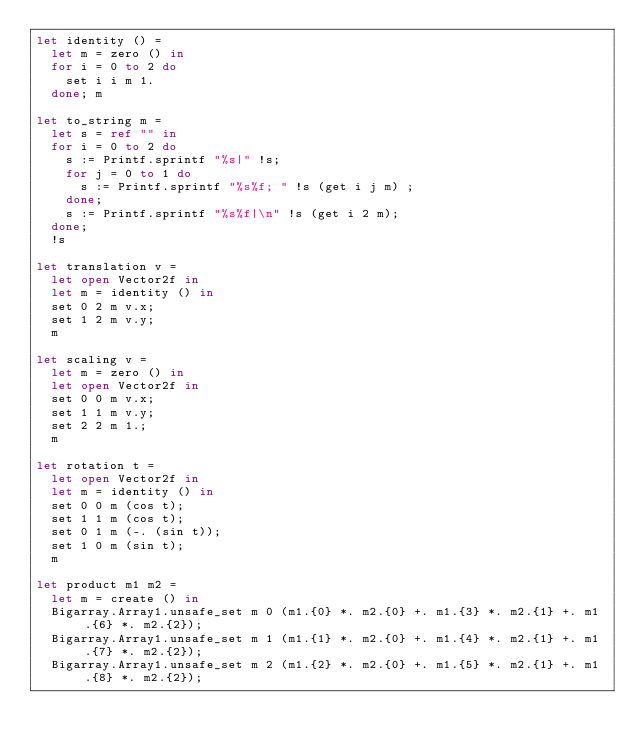Convert code to text. <code><loc_0><loc_0><loc_500><loc_500><_OCaml_>let identity () = 
  let m = zero () in
  for i = 0 to 2 do
    set i i m 1.
  done; m

let to_string m = 
  let s = ref "" in
  for i = 0 to 2 do
    s := Printf.sprintf "%s|" !s;
    for j = 0 to 1 do
      s := Printf.sprintf "%s%f; " !s (get i j m) ;
    done;
    s := Printf.sprintf "%s%f|\n" !s (get i 2 m);
  done;
  !s

let translation v = 
  let open Vector2f in
  let m = identity () in
  set 0 2 m v.x;
  set 1 2 m v.y;
  m

let scaling v = 
  let m = zero () in
  let open Vector2f in
  set 0 0 m v.x;
  set 1 1 m v.y;
  set 2 2 m 1.;
  m

let rotation t = 
  let open Vector2f in
  let m = identity () in
  set 0 0 m (cos t);
  set 1 1 m (cos t);
  set 0 1 m (-. (sin t));
  set 1 0 m (sin t);
  m

let product m1 m2 = 
  let m = create () in
  Bigarray.Array1.unsafe_set m 0 (m1.{0} *. m2.{0} +. m1.{3} *. m2.{1} +. m1.{6} *. m2.{2});
  Bigarray.Array1.unsafe_set m 1 (m1.{1} *. m2.{0} +. m1.{4} *. m2.{1} +. m1.{7} *. m2.{2});
  Bigarray.Array1.unsafe_set m 2 (m1.{2} *. m2.{0} +. m1.{5} *. m2.{1} +. m1.{8} *. m2.{2});</code> 